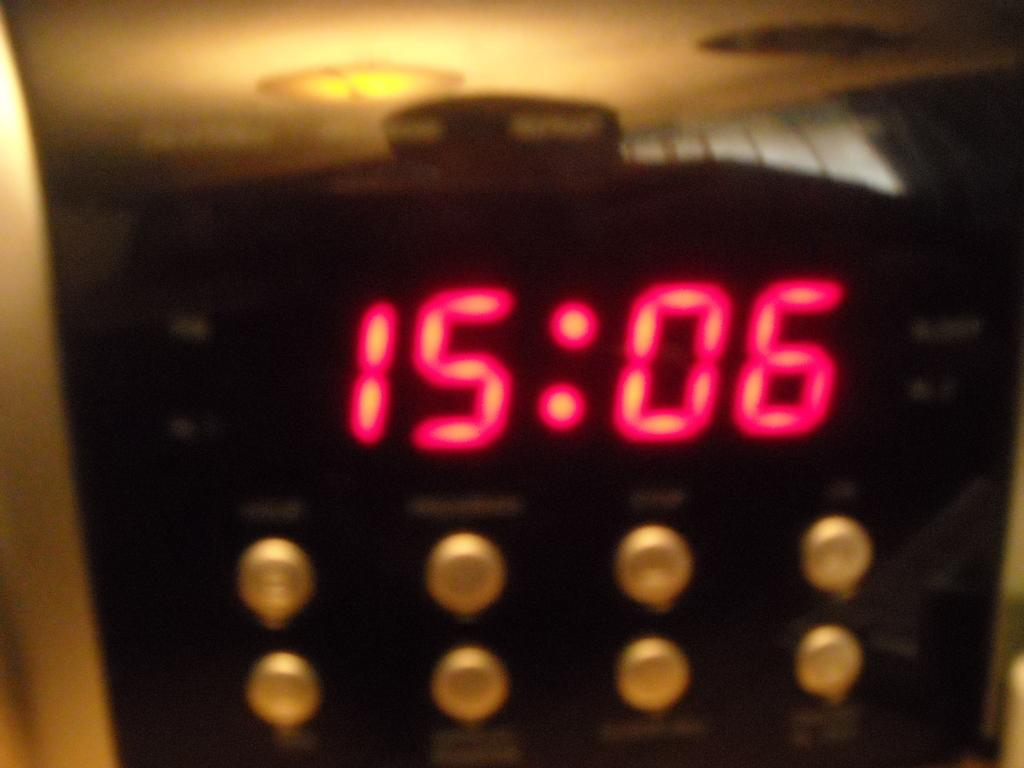<image>
Provide a brief description of the given image. A digital display that reads 15:06 in red digits. 